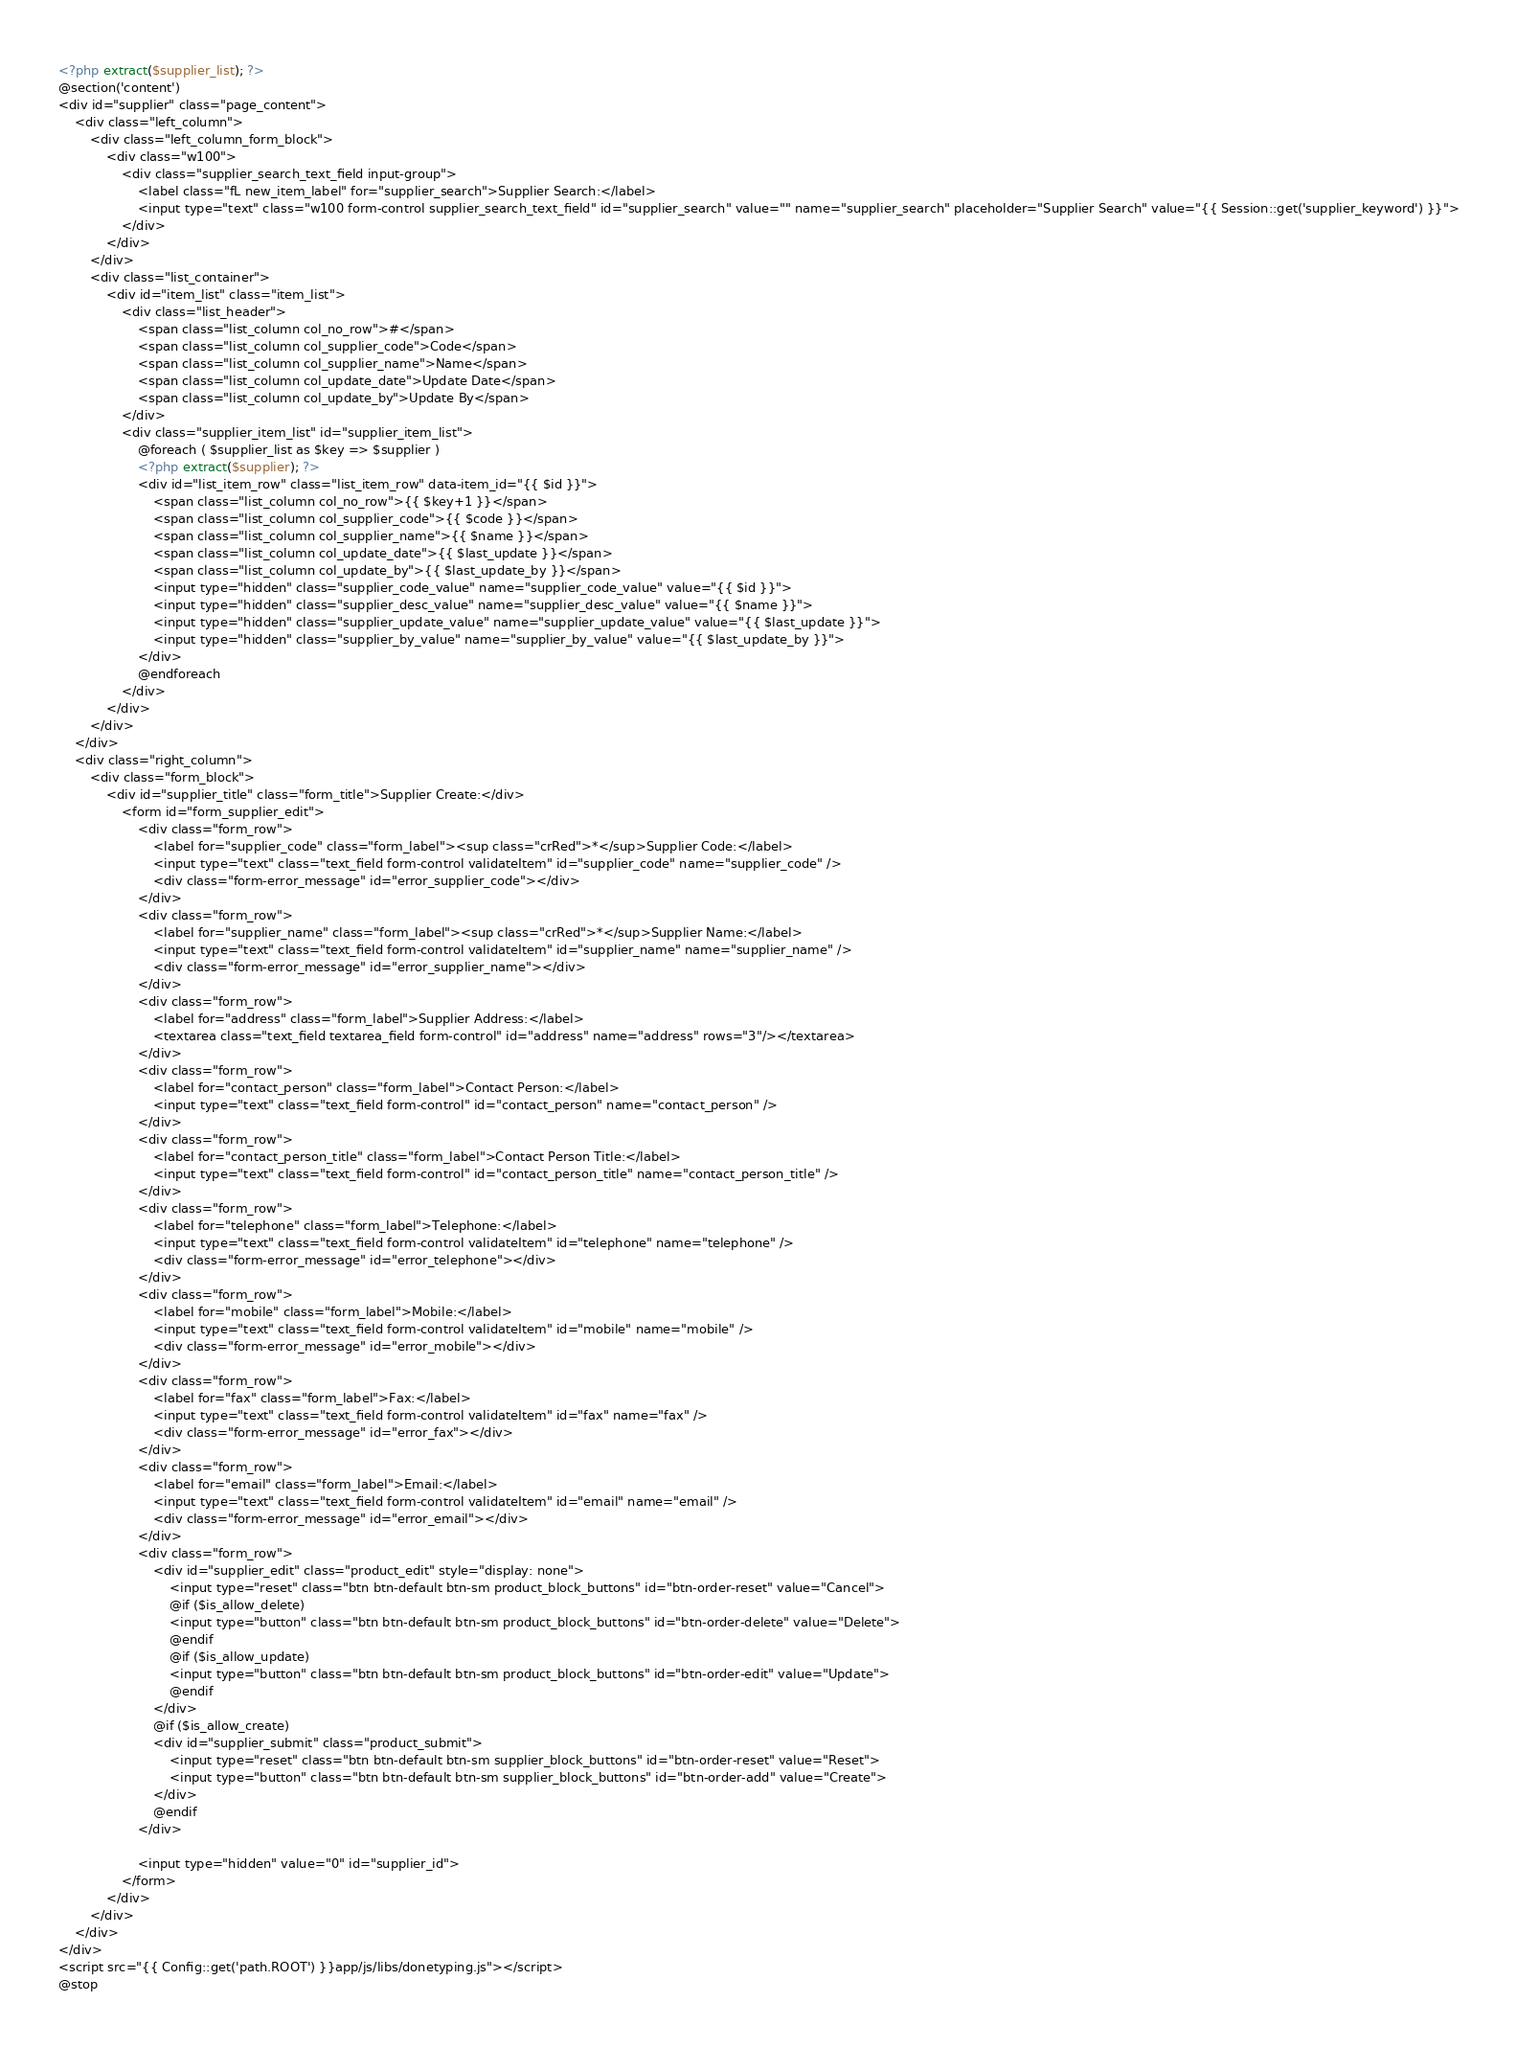Convert code to text. <code><loc_0><loc_0><loc_500><loc_500><_PHP_><?php extract($supplier_list); ?>
@section('content')
<div id="supplier" class="page_content">
    <div class="left_column">
		<div class="left_column_form_block">
			<div class="w100">
				<div class="supplier_search_text_field input-group">
					<label class="fL new_item_label" for="supplier_search">Supplier Search:</label>
					<input type="text" class="w100 form-control supplier_search_text_field" id="supplier_search" value="" name="supplier_search" placeholder="Supplier Search" value="{{ Session::get('supplier_keyword') }}">
				</div>
			</div>
		</div>
		<div class="list_container">
			<div id="item_list" class="item_list">
				<div class="list_header">
					<span class="list_column col_no_row">#</span>
					<span class="list_column col_supplier_code">Code</span>
					<span class="list_column col_supplier_name">Name</span>
					<span class="list_column col_update_date">Update Date</span>
					<span class="list_column col_update_by">Update By</span>
				</div>
				<div class="supplier_item_list" id="supplier_item_list">
					@foreach ( $supplier_list as $key => $supplier )
					<?php extract($supplier); ?>
					<div id="list_item_row" class="list_item_row" data-item_id="{{ $id }}">
						<span class="list_column col_no_row">{{ $key+1 }}</span>
						<span class="list_column col_supplier_code">{{ $code }}</span>
						<span class="list_column col_supplier_name">{{ $name }}</span>
						<span class="list_column col_update_date">{{ $last_update }}</span>
						<span class="list_column col_update_by">{{ $last_update_by }}</span>
						<input type="hidden" class="supplier_code_value" name="supplier_code_value" value="{{ $id }}">
						<input type="hidden" class="supplier_desc_value" name="supplier_desc_value" value="{{ $name }}">
						<input type="hidden" class="supplier_update_value" name="supplier_update_value" value="{{ $last_update }}">
						<input type="hidden" class="supplier_by_value" name="supplier_by_value" value="{{ $last_update_by }}">
					</div>
					@endforeach
				</div>
			</div>
		</div>
	</div>
	<div class="right_column">
		<div class="form_block">
			<div id="supplier_title" class="form_title">Supplier Create:</div>
				<form id="form_supplier_edit">
					<div class="form_row">
						<label for="supplier_code" class="form_label"><sup class="crRed">*</sup>Supplier Code:</label>
						<input type="text" class="text_field form-control validateItem" id="supplier_code" name="supplier_code" />
						<div class="form-error_message" id="error_supplier_code"></div>
					</div>
					<div class="form_row">
						<label for="supplier_name" class="form_label"><sup class="crRed">*</sup>Supplier Name:</label>
						<input type="text" class="text_field form-control validateItem" id="supplier_name" name="supplier_name" />
						<div class="form-error_message" id="error_supplier_name"></div>
					</div>
					<div class="form_row">
						<label for="address" class="form_label">Supplier Address:</label>
						<textarea class="text_field textarea_field form-control" id="address" name="address" rows="3"/></textarea>
					</div>
					<div class="form_row">
						<label for="contact_person" class="form_label">Contact Person:</label>
						<input type="text" class="text_field form-control" id="contact_person" name="contact_person" />
					</div>
					<div class="form_row">
						<label for="contact_person_title" class="form_label">Contact Person Title:</label>
						<input type="text" class="text_field form-control" id="contact_person_title" name="contact_person_title" />
					</div>
					<div class="form_row">
						<label for="telephone" class="form_label">Telephone:</label>
						<input type="text" class="text_field form-control validateItem" id="telephone" name="telephone" />
						<div class="form-error_message" id="error_telephone"></div>
					</div>
					<div class="form_row">
						<label for="mobile" class="form_label">Mobile:</label>
						<input type="text" class="text_field form-control validateItem" id="mobile" name="mobile" />
						<div class="form-error_message" id="error_mobile"></div>
					</div>
					<div class="form_row">
						<label for="fax" class="form_label">Fax:</label>
						<input type="text" class="text_field form-control validateItem" id="fax" name="fax" />
						<div class="form-error_message" id="error_fax"></div>
					</div>
					<div class="form_row">
						<label for="email" class="form_label">Email:</label>
						<input type="text" class="text_field form-control validateItem" id="email" name="email" />
						<div class="form-error_message" id="error_email"></div>
					</div>
					<div class="form_row">
						<div id="supplier_edit" class="product_edit" style="display: none">
							<input type="reset" class="btn btn-default btn-sm product_block_buttons" id="btn-order-reset" value="Cancel">
							@if ($is_allow_delete)
							<input type="button" class="btn btn-default btn-sm product_block_buttons" id="btn-order-delete" value="Delete">
							@endif
							@if ($is_allow_update)
							<input type="button" class="btn btn-default btn-sm product_block_buttons" id="btn-order-edit" value="Update">
							@endif
						</div>
						@if ($is_allow_create)
						<div id="supplier_submit" class="product_submit">
							<input type="reset" class="btn btn-default btn-sm supplier_block_buttons" id="btn-order-reset" value="Reset">
							<input type="button" class="btn btn-default btn-sm supplier_block_buttons" id="btn-order-add" value="Create">
						</div>
						@endif
					</div>

					<input type="hidden" value="0" id="supplier_id">
				</form>
			</div>
		</div>
	</div>
</div>
<script src="{{ Config::get('path.ROOT') }}app/js/libs/donetyping.js"></script>
@stop</code> 